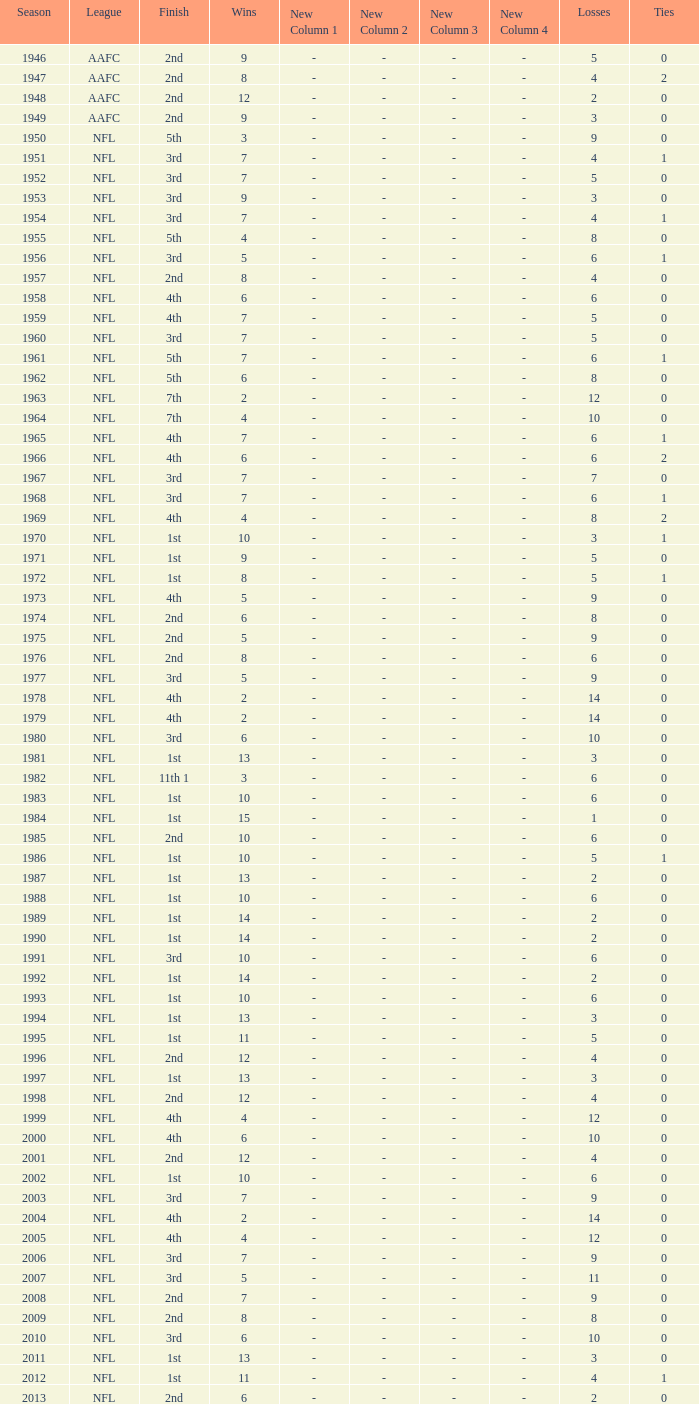What is the highest wins for the NFL with a finish of 1st, and more than 6 losses? None. 